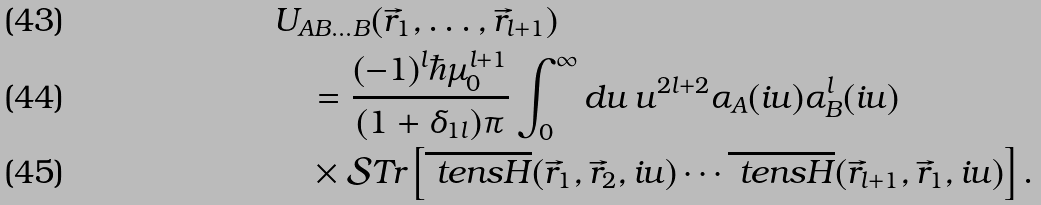Convert formula to latex. <formula><loc_0><loc_0><loc_500><loc_500>& U _ { A B \dots B } ( \vec { r } _ { 1 } , \dots , \vec { r } _ { l + 1 } ) \\ & \quad = \frac { ( - 1 ) ^ { l } \hbar { \mu } _ { 0 } ^ { l + 1 } } { ( 1 + \delta _ { 1 l } ) \pi } \int _ { 0 } ^ { \infty } d u \, u ^ { 2 l + 2 } \alpha _ { A } ( i u ) \alpha _ { B } ^ { l } ( i u ) \\ & \quad \times \mathcal { S } T r \left [ \overline { \ t e n s { H } } ( \vec { r } _ { 1 } , \vec { r } _ { 2 } , i u ) \cdots \overline { \ t e n s { H } } ( \vec { r } _ { l + 1 } , \vec { r } _ { 1 } , i u ) \right ] .</formula> 